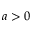Convert formula to latex. <formula><loc_0><loc_0><loc_500><loc_500>a > 0</formula> 